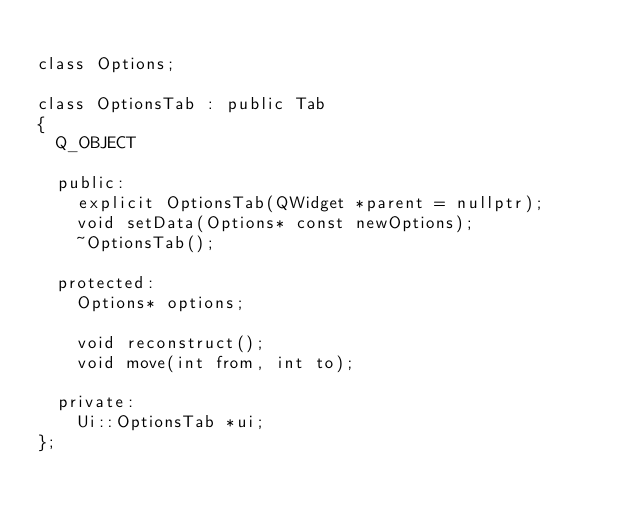Convert code to text. <code><loc_0><loc_0><loc_500><loc_500><_C_>
class Options;

class OptionsTab : public Tab
{
	Q_OBJECT

	public:
		explicit OptionsTab(QWidget *parent = nullptr);
		void setData(Options* const newOptions);
		~OptionsTab();

	protected:
		Options* options;

		void reconstruct();
		void move(int from, int to);

	private:
		Ui::OptionsTab *ui;
};

</code> 